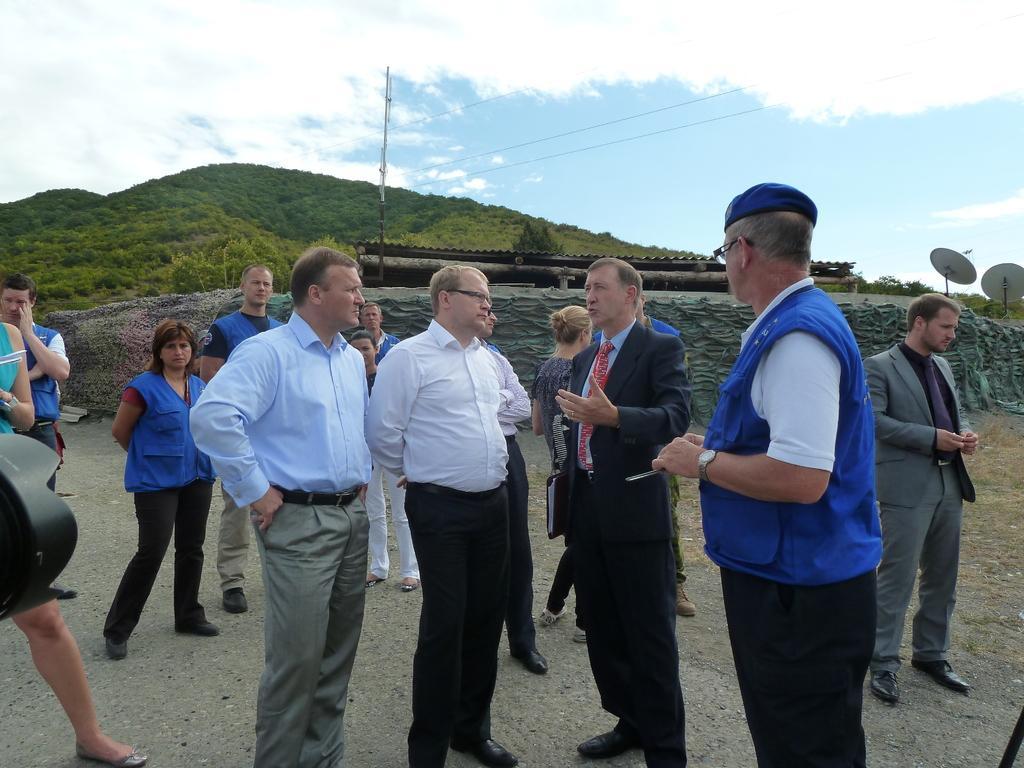In one or two sentences, can you explain what this image depicts? In this image, we can see there are persons in different color dresses, standing on a road. One of them is speaking who is in a suit. In the background, there are two antennas, electric lines attached to a pole, trees on a mountain and there are clouds in the blue sky. 